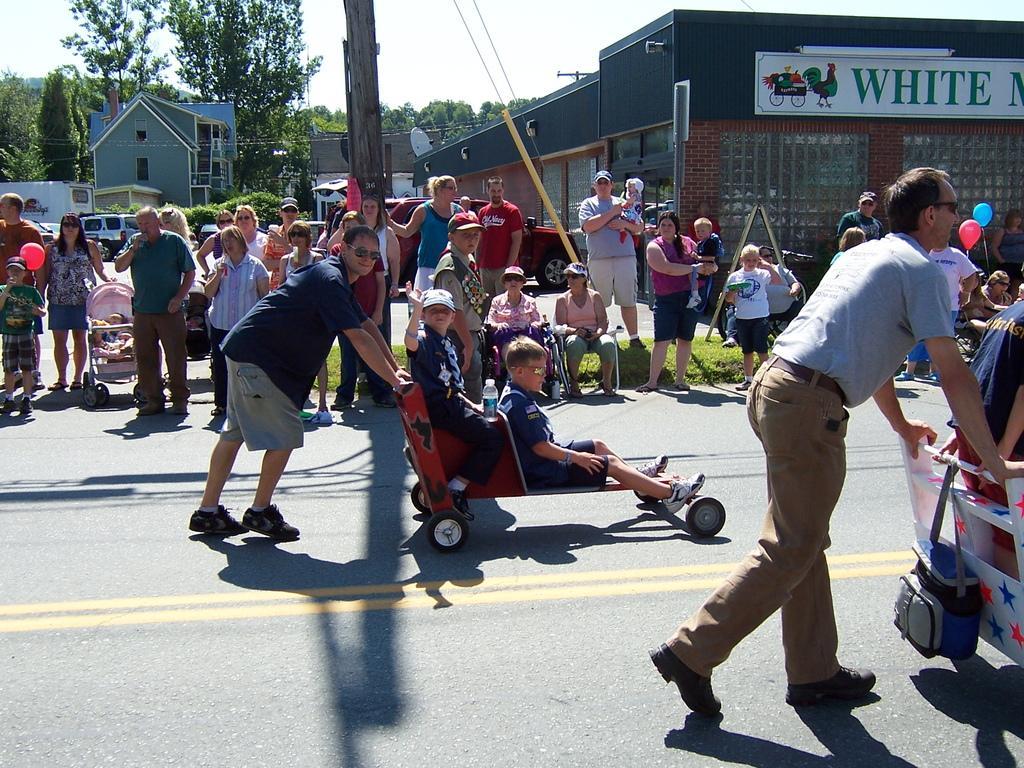How would you summarize this image in a sentence or two? This picture is taken beside the road. On the road there is a person pushing the vehicle. On the vehicle, there are two kids. The man is wearing a blue t shirt and grey shorts. On the vehicle, there are two kids wearing blue t shirts. Towards the right, there is another man wearing grey t shirt and cream trousers and he is also pushing the vehicle and there is a bag attached to it. Beside the road, on the footpath, there are people staring them. In the background there are buildings, trees and a sky. 